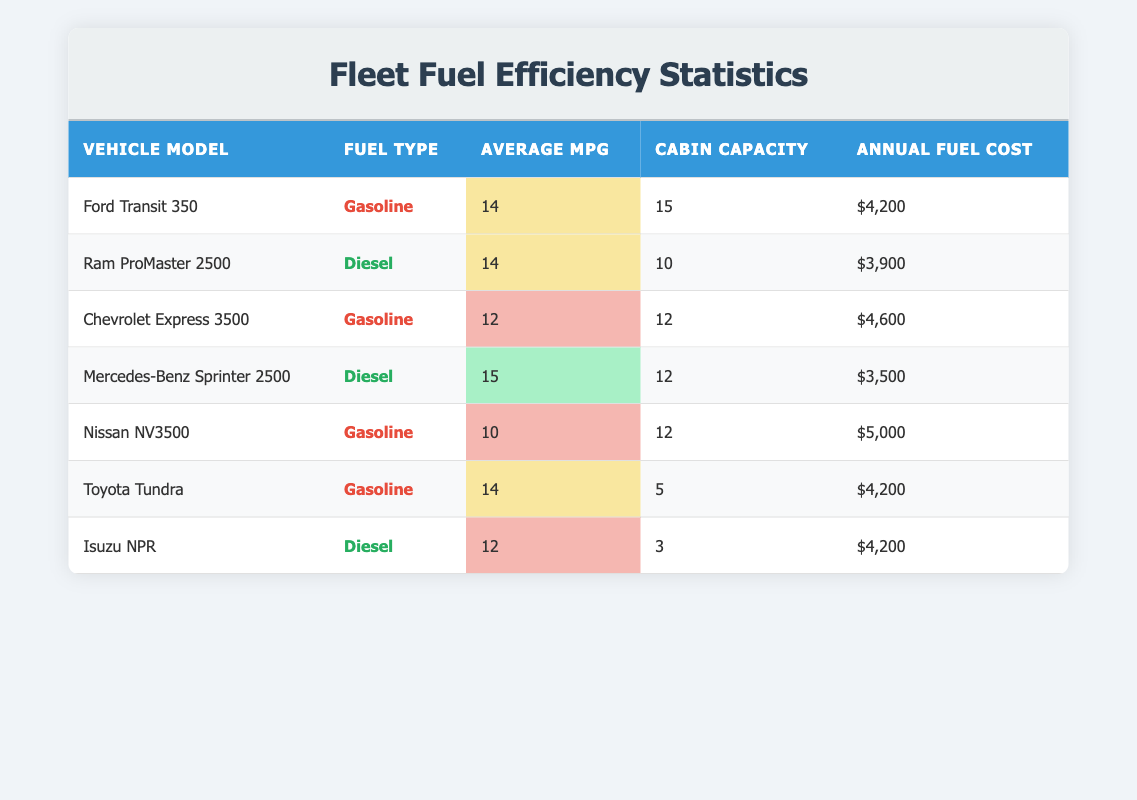What is the average MPG of the Ford Transit 350? The table shows that the Ford Transit 350 has an average MPG of 14, which can be found directly in the table under the "Average MPG" column.
Answer: 14 Which vehicle has the highest cabin capacity? By examining the "Cabin Capacity" column, the Ford Transit 350 has a capacity of 15, which is higher than the other vehicles in the table.
Answer: Ford Transit 350 Is the annual fuel cost of the Ram ProMaster 2500 lower than that of the Mercedes-Benz Sprinter 2500? The annual fuel cost for the Ram ProMaster 2500 is $3,900, while for the Mercedes-Benz Sprinter 2500 it is $3,500. Since $3,900 is greater than $3,500, the Ram ProMaster 2500 does not have a lower cost.
Answer: No What is the total annual fuel cost for all gasoline vehicles? The annual fuel costs for gasoline vehicles are $4,200 (Ford Transit 350) + $4,600 (Chevrolet Express 3500) + $5,000 (Nissan NV3500) + $4,200 (Toyota Tundra), totaling $18,000. Therefore, the total annual fuel cost for gasoline vehicles is $18,000.
Answer: $18,000 Which vehicle has the lowest average MPG? The data shows that the Nissan NV3500 has the lowest average MPG at 10. A comparison of the "Average MPG" values shows that no other vehicle has a lower figure.
Answer: Nissan NV3500 Is it true that all diesel vehicles in the table have an average MPG greater than 12? The table lists two diesel vehicles, the Ram ProMaster 2500 with 14 MPG and the Mercedes-Benz Sprinter 2500 with 15 MPG, both of which are greater than 12 MPG. Therefore, the statement is true.
Answer: Yes What is the difference in annual fuel costs between the highest and lowest fuel cost vehicles? The highest annual fuel cost is $5,000 (Nissan NV3500), and the lowest is $3,500 (Mercedes-Benz Sprinter 2500). The difference is $5,000 - $3,500 = $1,500.
Answer: $1,500 How many vehicles have an average MPG of 14? By checking the "Average MPG" column, both the Ford Transit 350 and the Toyota Tundra have an average MPG of 14, which means there are two vehicles with this fuel efficiency.
Answer: 2 What is the average cabin capacity of all vehicles listed in the table? Adding the cabin capacities: 15 (Ford Transit 350) + 10 (Ram ProMaster 2500) + 12 (Chevrolet Express 3500) + 12 (Mercedes-Benz Sprinter 2500) + 12 (Nissan NV3500) + 5 (Toyota Tundra) + 3 (Isuzu NPR) gives 79. Dividing by the number of vehicles (7) results in an average of 11.29.
Answer: 11.29 